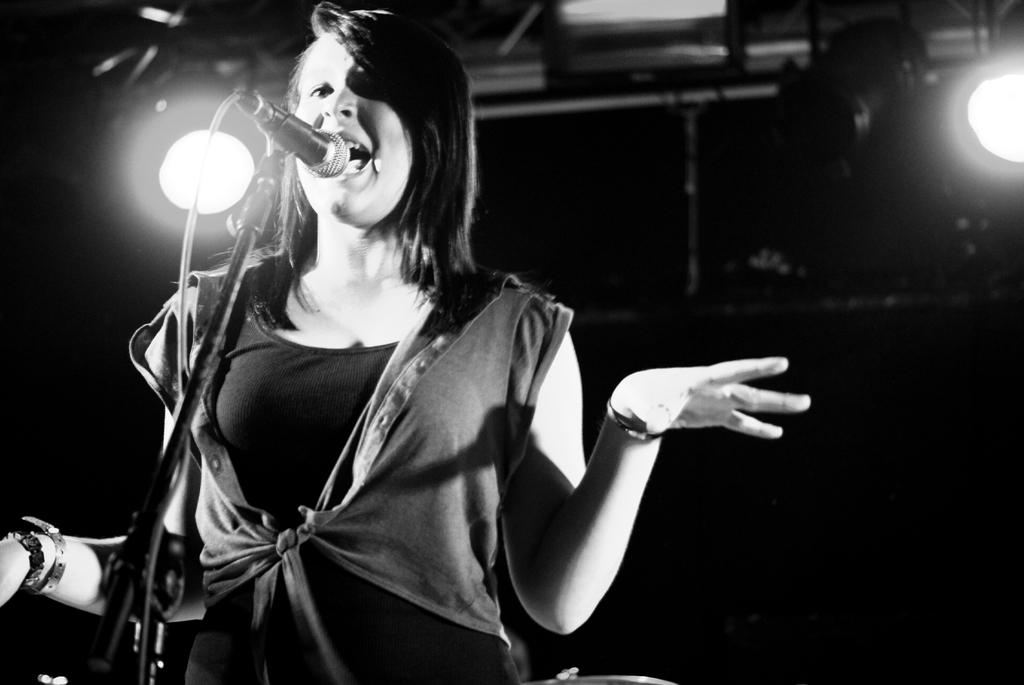Who is the main subject in the image? There is a woman in the image. What is the woman doing in the image? The woman is standing in front of a microphone. What can be seen behind the woman in the image? There are lights present behind the woman. How many ladybugs can be seen on the woman's shoulder in the image? There are no ladybugs present in the image. What type of horse is standing next to the woman in the image? There is no horse present in the image. 